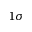Convert formula to latex. <formula><loc_0><loc_0><loc_500><loc_500>1 \sigma</formula> 